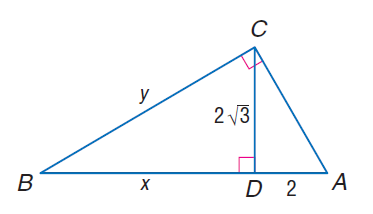Answer the mathemtical geometry problem and directly provide the correct option letter.
Question: Find x.
Choices: A: 3 B: 2 \sqrt { 3 } C: 6 D: 4 \sqrt { 3 } C 